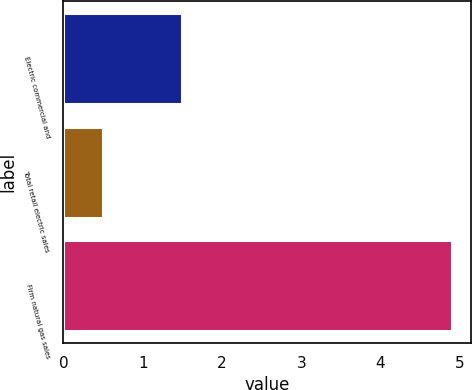<chart> <loc_0><loc_0><loc_500><loc_500><bar_chart><fcel>Electric commercial and<fcel>Total retail electric sales<fcel>Firm natural gas sales<nl><fcel>1.5<fcel>0.5<fcel>4.9<nl></chart> 